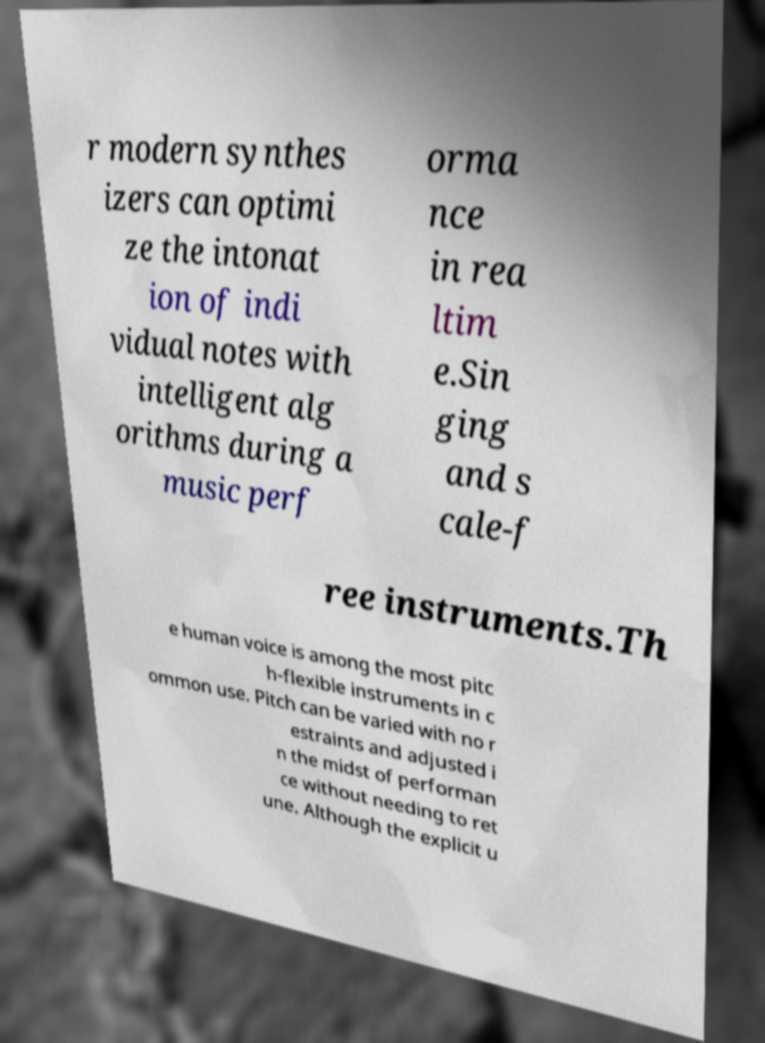Can you accurately transcribe the text from the provided image for me? r modern synthes izers can optimi ze the intonat ion of indi vidual notes with intelligent alg orithms during a music perf orma nce in rea ltim e.Sin ging and s cale-f ree instruments.Th e human voice is among the most pitc h-flexible instruments in c ommon use. Pitch can be varied with no r estraints and adjusted i n the midst of performan ce without needing to ret une. Although the explicit u 